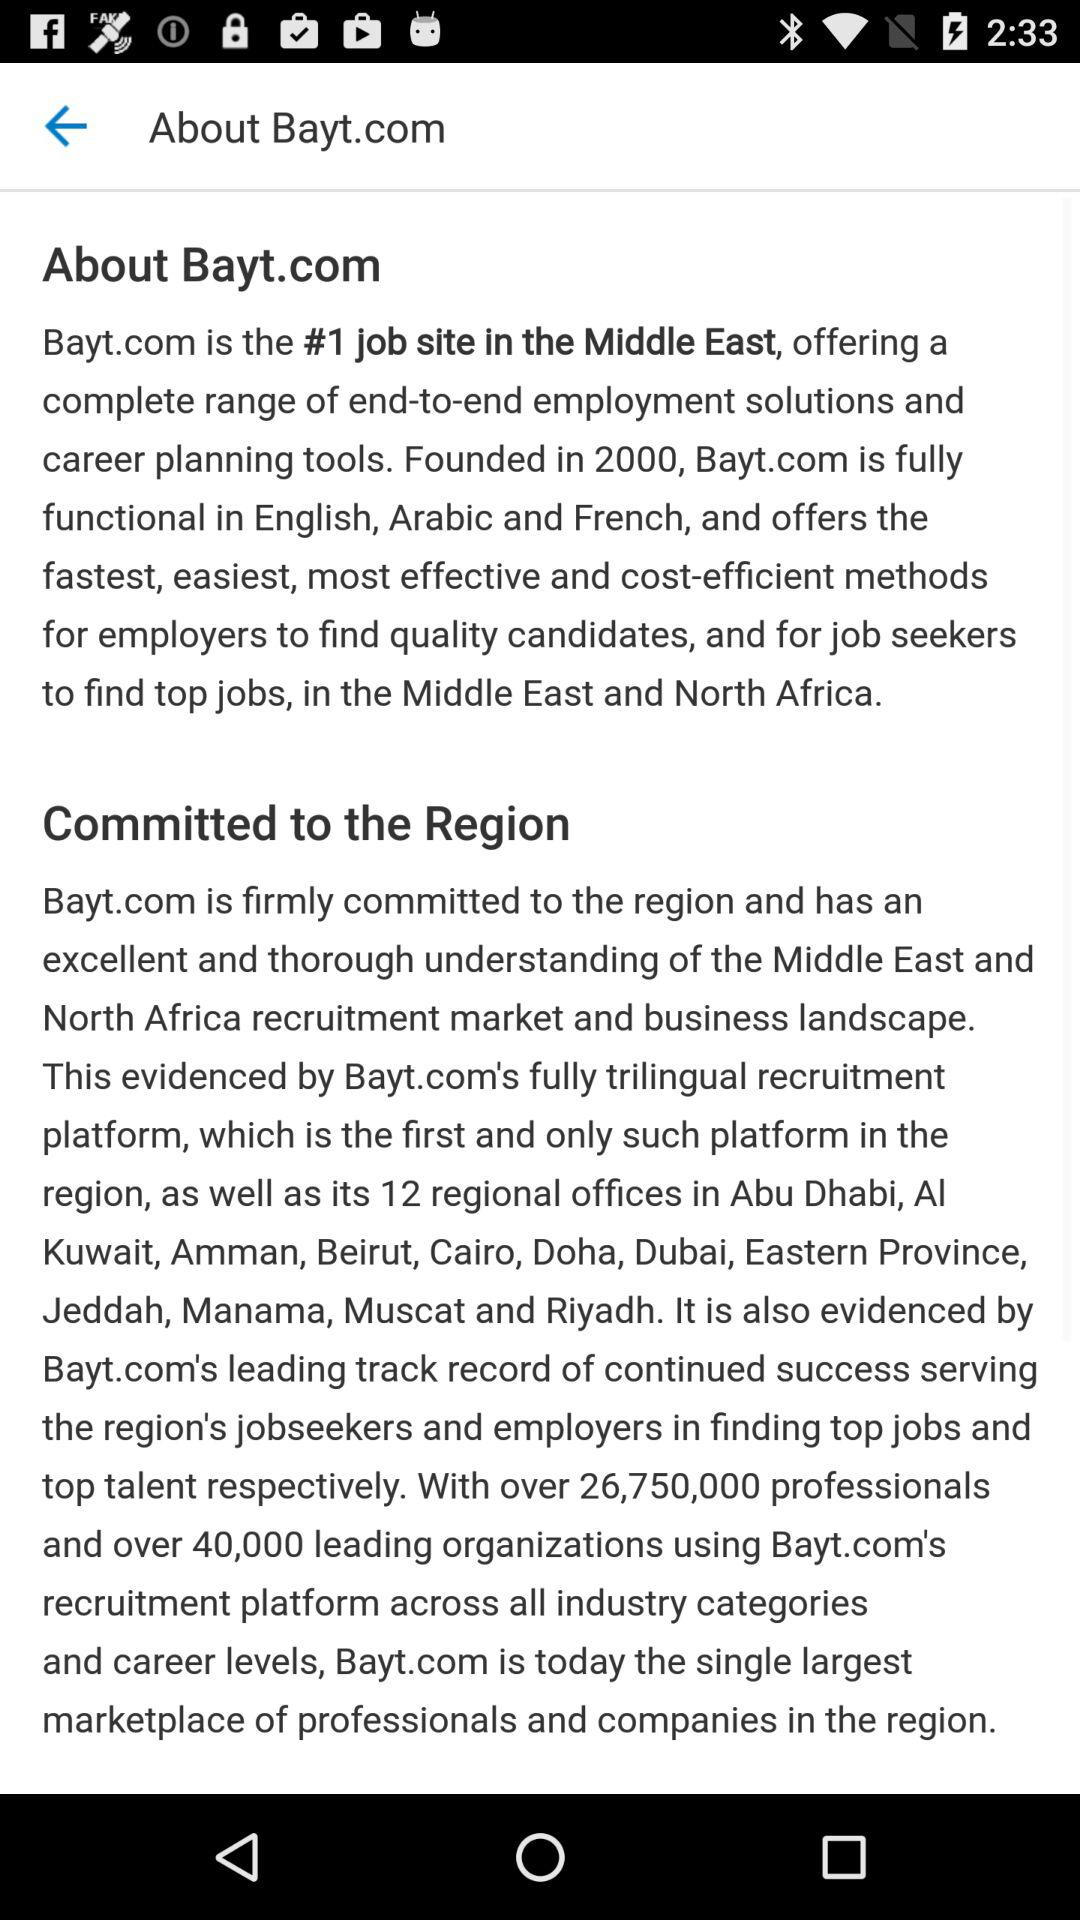How many languages does Bayt.com support?
Answer the question using a single word or phrase. 3 